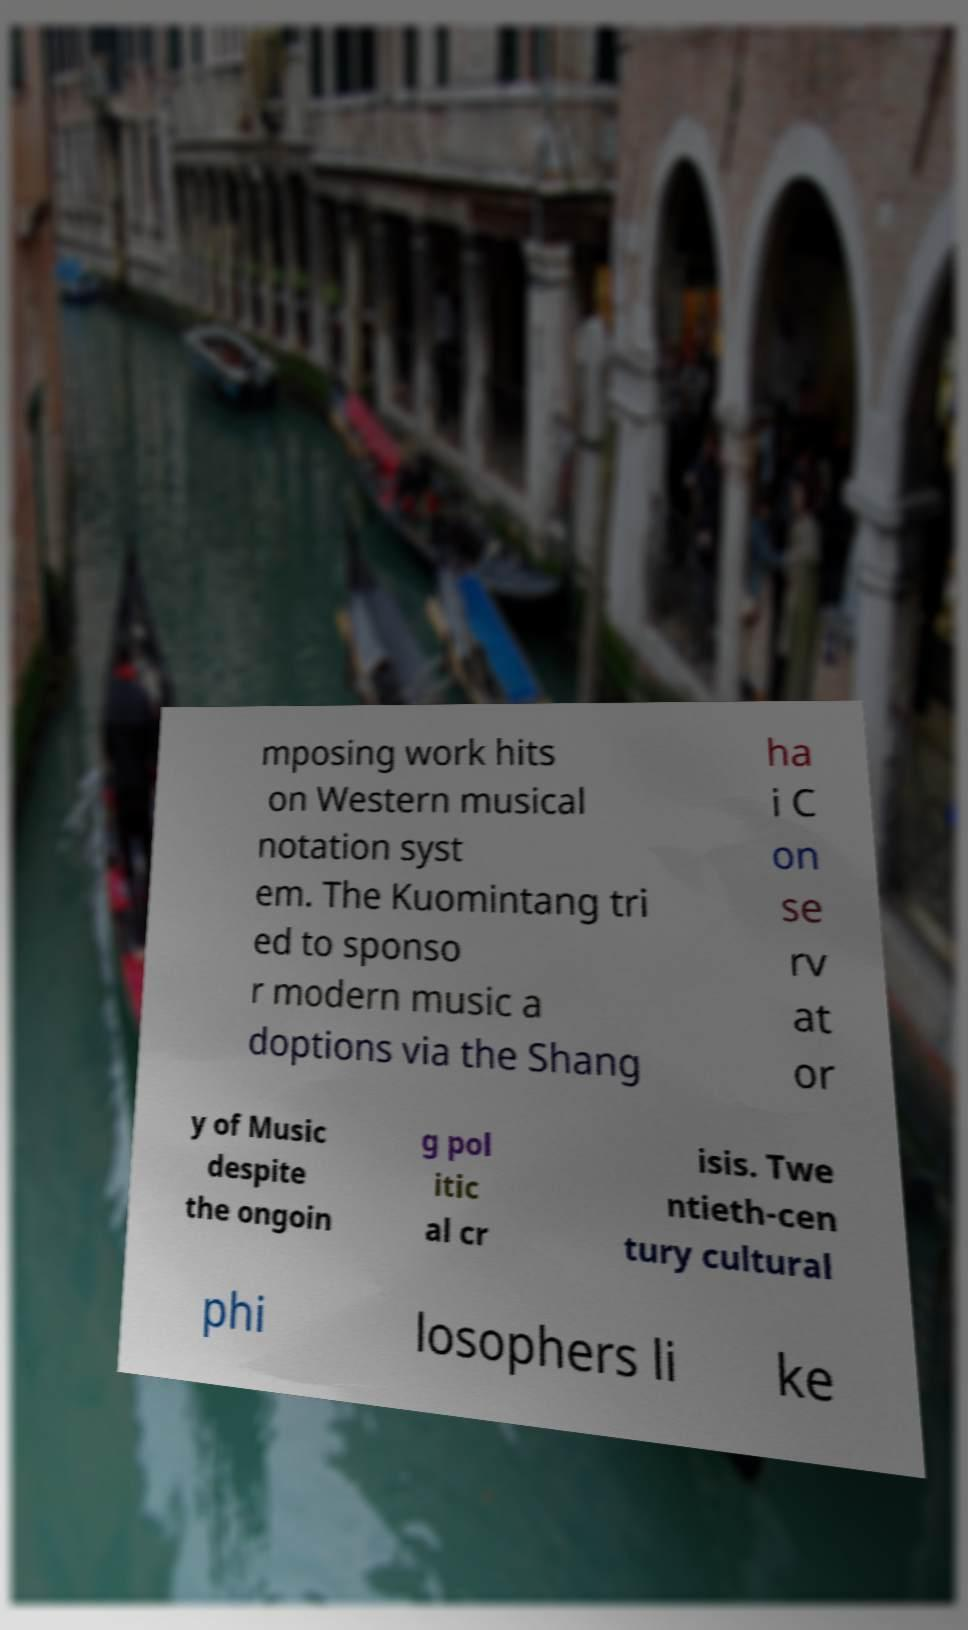Can you accurately transcribe the text from the provided image for me? mposing work hits on Western musical notation syst em. The Kuomintang tri ed to sponso r modern music a doptions via the Shang ha i C on se rv at or y of Music despite the ongoin g pol itic al cr isis. Twe ntieth-cen tury cultural phi losophers li ke 